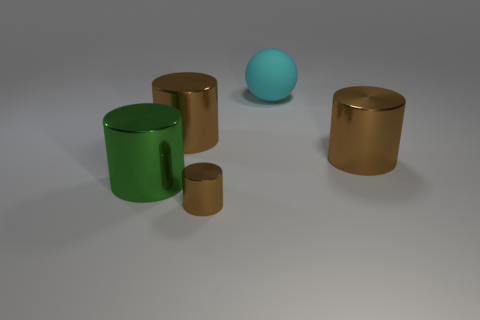Is there anything else that is the same shape as the big cyan thing?
Offer a very short reply. No. How many objects are either large brown cylinders on the right side of the small metal object or brown matte cylinders?
Offer a terse response. 1. Does the large metallic thing on the right side of the big cyan matte ball have the same color as the small metallic object?
Offer a terse response. Yes. There is a cyan rubber thing that is to the right of the brown object in front of the green shiny thing; what shape is it?
Your answer should be compact. Sphere. Is the number of cyan objects in front of the green cylinder less than the number of brown cylinders to the right of the sphere?
Your answer should be very brief. Yes. How many things are cylinders behind the green metal thing or big cylinders to the left of the big cyan thing?
Provide a succinct answer. 3. Is the size of the green shiny thing the same as the cyan ball?
Offer a terse response. Yes. Is the number of big brown things greater than the number of brown matte spheres?
Ensure brevity in your answer.  Yes. What number of other objects are the same color as the matte thing?
Provide a short and direct response. 0. How many objects are large cyan things or tiny red matte cylinders?
Give a very brief answer. 1. 